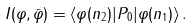Convert formula to latex. <formula><loc_0><loc_0><loc_500><loc_500>I ( \varphi , \bar { \varphi } ) = \langle \varphi ( n _ { 2 } ) | P _ { 0 } | \varphi ( n _ { 1 } ) \rangle \, .</formula> 